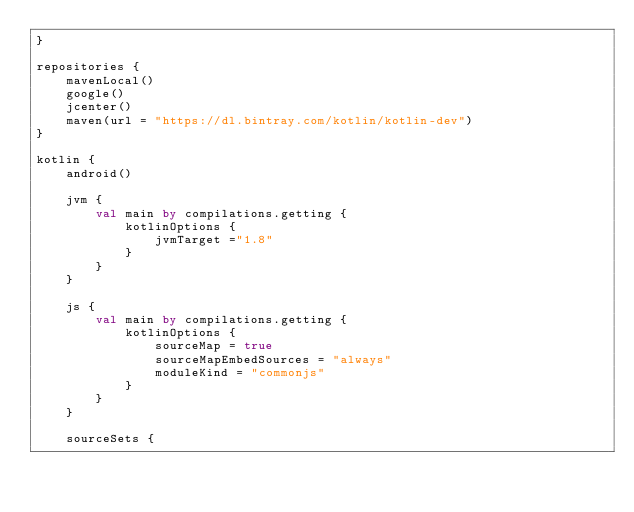<code> <loc_0><loc_0><loc_500><loc_500><_Kotlin_>}

repositories {
    mavenLocal()
    google()
    jcenter()
    maven(url = "https://dl.bintray.com/kotlin/kotlin-dev")
}

kotlin {
    android()

    jvm {
        val main by compilations.getting {
            kotlinOptions {
                jvmTarget ="1.8"
            }
        }
    }

    js {
        val main by compilations.getting {
            kotlinOptions {
                sourceMap = true
                sourceMapEmbedSources = "always"
                moduleKind = "commonjs"
            }
        }
    }

    sourceSets {</code> 